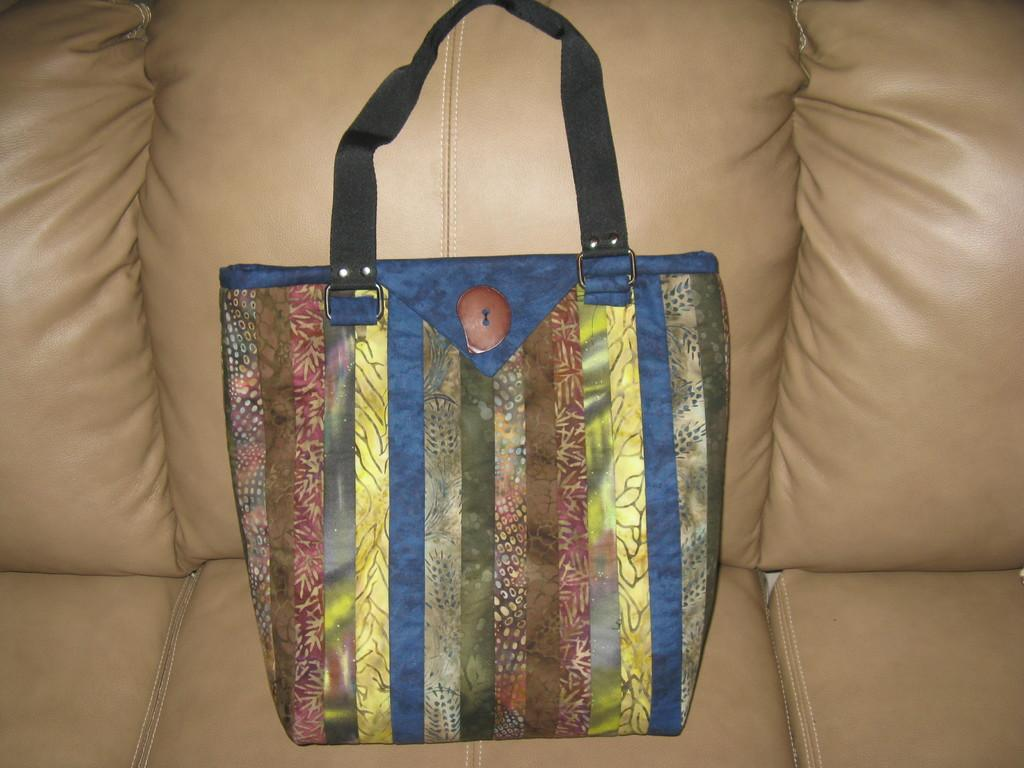What object can be seen in the image? There is a bag in the image. Can you describe the appearance of the bag? The bag is colorful. Where is the bag located in the image? The bag is on a couch. Is the lettuce causing trouble in the oven in the image? There is no lettuce or oven present in the image, so this scenario cannot be observed. 